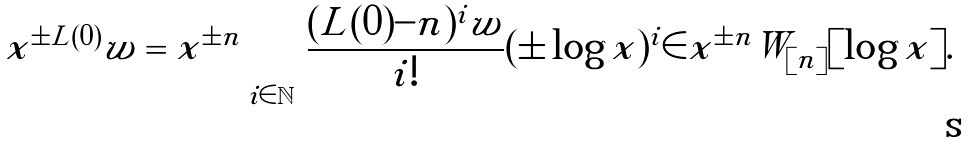<formula> <loc_0><loc_0><loc_500><loc_500>x ^ { \pm L ( 0 ) } w = x ^ { \pm n } \sum _ { i \in { \mathbb { N } } } \frac { ( L ( 0 ) - n ) ^ { i } w } { i ! } ( \pm \log x ) ^ { i } \in x ^ { \pm n } W _ { [ n ] } [ \log x ] .</formula> 